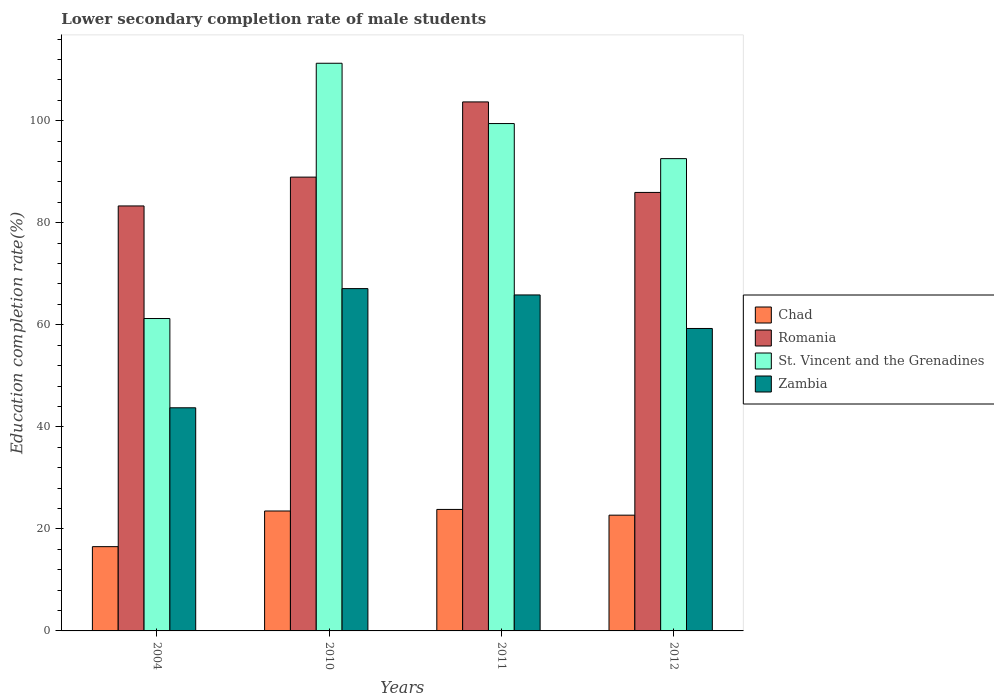How many different coloured bars are there?
Ensure brevity in your answer.  4. Are the number of bars per tick equal to the number of legend labels?
Your response must be concise. Yes. What is the label of the 2nd group of bars from the left?
Your answer should be compact. 2010. What is the lower secondary completion rate of male students in St. Vincent and the Grenadines in 2004?
Ensure brevity in your answer.  61.23. Across all years, what is the maximum lower secondary completion rate of male students in Chad?
Provide a short and direct response. 23.81. Across all years, what is the minimum lower secondary completion rate of male students in St. Vincent and the Grenadines?
Offer a terse response. 61.23. What is the total lower secondary completion rate of male students in Chad in the graph?
Your answer should be compact. 86.52. What is the difference between the lower secondary completion rate of male students in St. Vincent and the Grenadines in 2010 and that in 2012?
Your response must be concise. 18.69. What is the difference between the lower secondary completion rate of male students in Chad in 2010 and the lower secondary completion rate of male students in Zambia in 2004?
Offer a very short reply. -20.23. What is the average lower secondary completion rate of male students in Chad per year?
Provide a short and direct response. 21.63. In the year 2010, what is the difference between the lower secondary completion rate of male students in Romania and lower secondary completion rate of male students in St. Vincent and the Grenadines?
Offer a terse response. -22.31. In how many years, is the lower secondary completion rate of male students in Romania greater than 44 %?
Offer a terse response. 4. What is the ratio of the lower secondary completion rate of male students in Zambia in 2004 to that in 2012?
Your answer should be very brief. 0.74. Is the difference between the lower secondary completion rate of male students in Romania in 2004 and 2010 greater than the difference between the lower secondary completion rate of male students in St. Vincent and the Grenadines in 2004 and 2010?
Your answer should be very brief. Yes. What is the difference between the highest and the second highest lower secondary completion rate of male students in Romania?
Provide a short and direct response. 14.74. What is the difference between the highest and the lowest lower secondary completion rate of male students in Chad?
Provide a succinct answer. 7.3. Is the sum of the lower secondary completion rate of male students in St. Vincent and the Grenadines in 2011 and 2012 greater than the maximum lower secondary completion rate of male students in Chad across all years?
Your answer should be very brief. Yes. What does the 4th bar from the left in 2012 represents?
Keep it short and to the point. Zambia. What does the 1st bar from the right in 2011 represents?
Your response must be concise. Zambia. How many bars are there?
Provide a short and direct response. 16. What is the difference between two consecutive major ticks on the Y-axis?
Your response must be concise. 20. Are the values on the major ticks of Y-axis written in scientific E-notation?
Your response must be concise. No. Does the graph contain grids?
Make the answer very short. No. Where does the legend appear in the graph?
Your response must be concise. Center right. How many legend labels are there?
Ensure brevity in your answer.  4. What is the title of the graph?
Your response must be concise. Lower secondary completion rate of male students. What is the label or title of the Y-axis?
Your response must be concise. Education completion rate(%). What is the Education completion rate(%) in Chad in 2004?
Make the answer very short. 16.52. What is the Education completion rate(%) of Romania in 2004?
Offer a terse response. 83.29. What is the Education completion rate(%) in St. Vincent and the Grenadines in 2004?
Ensure brevity in your answer.  61.23. What is the Education completion rate(%) of Zambia in 2004?
Give a very brief answer. 43.73. What is the Education completion rate(%) of Chad in 2010?
Ensure brevity in your answer.  23.51. What is the Education completion rate(%) in Romania in 2010?
Provide a succinct answer. 88.94. What is the Education completion rate(%) of St. Vincent and the Grenadines in 2010?
Keep it short and to the point. 111.26. What is the Education completion rate(%) in Zambia in 2010?
Your answer should be very brief. 67.09. What is the Education completion rate(%) of Chad in 2011?
Your response must be concise. 23.81. What is the Education completion rate(%) in Romania in 2011?
Give a very brief answer. 103.68. What is the Education completion rate(%) of St. Vincent and the Grenadines in 2011?
Your response must be concise. 99.44. What is the Education completion rate(%) in Zambia in 2011?
Keep it short and to the point. 65.85. What is the Education completion rate(%) in Chad in 2012?
Provide a succinct answer. 22.69. What is the Education completion rate(%) in Romania in 2012?
Give a very brief answer. 85.94. What is the Education completion rate(%) in St. Vincent and the Grenadines in 2012?
Provide a short and direct response. 92.56. What is the Education completion rate(%) of Zambia in 2012?
Ensure brevity in your answer.  59.28. Across all years, what is the maximum Education completion rate(%) of Chad?
Your answer should be compact. 23.81. Across all years, what is the maximum Education completion rate(%) in Romania?
Offer a very short reply. 103.68. Across all years, what is the maximum Education completion rate(%) of St. Vincent and the Grenadines?
Provide a short and direct response. 111.26. Across all years, what is the maximum Education completion rate(%) of Zambia?
Your answer should be very brief. 67.09. Across all years, what is the minimum Education completion rate(%) in Chad?
Your response must be concise. 16.52. Across all years, what is the minimum Education completion rate(%) of Romania?
Ensure brevity in your answer.  83.29. Across all years, what is the minimum Education completion rate(%) in St. Vincent and the Grenadines?
Your answer should be compact. 61.23. Across all years, what is the minimum Education completion rate(%) in Zambia?
Offer a terse response. 43.73. What is the total Education completion rate(%) of Chad in the graph?
Offer a terse response. 86.52. What is the total Education completion rate(%) of Romania in the graph?
Your response must be concise. 361.85. What is the total Education completion rate(%) of St. Vincent and the Grenadines in the graph?
Keep it short and to the point. 364.48. What is the total Education completion rate(%) of Zambia in the graph?
Your answer should be compact. 235.95. What is the difference between the Education completion rate(%) in Chad in 2004 and that in 2010?
Offer a terse response. -6.99. What is the difference between the Education completion rate(%) of Romania in 2004 and that in 2010?
Ensure brevity in your answer.  -5.65. What is the difference between the Education completion rate(%) of St. Vincent and the Grenadines in 2004 and that in 2010?
Offer a very short reply. -50.03. What is the difference between the Education completion rate(%) in Zambia in 2004 and that in 2010?
Offer a very short reply. -23.36. What is the difference between the Education completion rate(%) in Chad in 2004 and that in 2011?
Keep it short and to the point. -7.3. What is the difference between the Education completion rate(%) in Romania in 2004 and that in 2011?
Your answer should be compact. -20.39. What is the difference between the Education completion rate(%) of St. Vincent and the Grenadines in 2004 and that in 2011?
Ensure brevity in your answer.  -38.21. What is the difference between the Education completion rate(%) of Zambia in 2004 and that in 2011?
Provide a succinct answer. -22.12. What is the difference between the Education completion rate(%) of Chad in 2004 and that in 2012?
Your response must be concise. -6.17. What is the difference between the Education completion rate(%) in Romania in 2004 and that in 2012?
Keep it short and to the point. -2.65. What is the difference between the Education completion rate(%) of St. Vincent and the Grenadines in 2004 and that in 2012?
Ensure brevity in your answer.  -31.34. What is the difference between the Education completion rate(%) of Zambia in 2004 and that in 2012?
Your answer should be very brief. -15.54. What is the difference between the Education completion rate(%) in Chad in 2010 and that in 2011?
Provide a short and direct response. -0.31. What is the difference between the Education completion rate(%) in Romania in 2010 and that in 2011?
Your answer should be very brief. -14.74. What is the difference between the Education completion rate(%) of St. Vincent and the Grenadines in 2010 and that in 2011?
Give a very brief answer. 11.82. What is the difference between the Education completion rate(%) in Zambia in 2010 and that in 2011?
Make the answer very short. 1.24. What is the difference between the Education completion rate(%) of Chad in 2010 and that in 2012?
Provide a succinct answer. 0.82. What is the difference between the Education completion rate(%) in Romania in 2010 and that in 2012?
Provide a succinct answer. 3. What is the difference between the Education completion rate(%) of St. Vincent and the Grenadines in 2010 and that in 2012?
Provide a short and direct response. 18.69. What is the difference between the Education completion rate(%) of Zambia in 2010 and that in 2012?
Offer a terse response. 7.82. What is the difference between the Education completion rate(%) of Chad in 2011 and that in 2012?
Your response must be concise. 1.12. What is the difference between the Education completion rate(%) of Romania in 2011 and that in 2012?
Your answer should be compact. 17.74. What is the difference between the Education completion rate(%) in St. Vincent and the Grenadines in 2011 and that in 2012?
Your response must be concise. 6.87. What is the difference between the Education completion rate(%) of Zambia in 2011 and that in 2012?
Offer a very short reply. 6.57. What is the difference between the Education completion rate(%) of Chad in 2004 and the Education completion rate(%) of Romania in 2010?
Offer a terse response. -72.42. What is the difference between the Education completion rate(%) of Chad in 2004 and the Education completion rate(%) of St. Vincent and the Grenadines in 2010?
Provide a short and direct response. -94.74. What is the difference between the Education completion rate(%) of Chad in 2004 and the Education completion rate(%) of Zambia in 2010?
Keep it short and to the point. -50.57. What is the difference between the Education completion rate(%) of Romania in 2004 and the Education completion rate(%) of St. Vincent and the Grenadines in 2010?
Provide a short and direct response. -27.96. What is the difference between the Education completion rate(%) of Romania in 2004 and the Education completion rate(%) of Zambia in 2010?
Your answer should be very brief. 16.2. What is the difference between the Education completion rate(%) of St. Vincent and the Grenadines in 2004 and the Education completion rate(%) of Zambia in 2010?
Provide a short and direct response. -5.87. What is the difference between the Education completion rate(%) of Chad in 2004 and the Education completion rate(%) of Romania in 2011?
Keep it short and to the point. -87.16. What is the difference between the Education completion rate(%) in Chad in 2004 and the Education completion rate(%) in St. Vincent and the Grenadines in 2011?
Provide a short and direct response. -82.92. What is the difference between the Education completion rate(%) in Chad in 2004 and the Education completion rate(%) in Zambia in 2011?
Provide a short and direct response. -49.33. What is the difference between the Education completion rate(%) of Romania in 2004 and the Education completion rate(%) of St. Vincent and the Grenadines in 2011?
Your answer should be very brief. -16.15. What is the difference between the Education completion rate(%) of Romania in 2004 and the Education completion rate(%) of Zambia in 2011?
Make the answer very short. 17.44. What is the difference between the Education completion rate(%) of St. Vincent and the Grenadines in 2004 and the Education completion rate(%) of Zambia in 2011?
Give a very brief answer. -4.62. What is the difference between the Education completion rate(%) of Chad in 2004 and the Education completion rate(%) of Romania in 2012?
Provide a succinct answer. -69.42. What is the difference between the Education completion rate(%) of Chad in 2004 and the Education completion rate(%) of St. Vincent and the Grenadines in 2012?
Ensure brevity in your answer.  -76.05. What is the difference between the Education completion rate(%) in Chad in 2004 and the Education completion rate(%) in Zambia in 2012?
Offer a very short reply. -42.76. What is the difference between the Education completion rate(%) in Romania in 2004 and the Education completion rate(%) in St. Vincent and the Grenadines in 2012?
Provide a succinct answer. -9.27. What is the difference between the Education completion rate(%) of Romania in 2004 and the Education completion rate(%) of Zambia in 2012?
Give a very brief answer. 24.02. What is the difference between the Education completion rate(%) of St. Vincent and the Grenadines in 2004 and the Education completion rate(%) of Zambia in 2012?
Keep it short and to the point. 1.95. What is the difference between the Education completion rate(%) of Chad in 2010 and the Education completion rate(%) of Romania in 2011?
Provide a succinct answer. -80.17. What is the difference between the Education completion rate(%) of Chad in 2010 and the Education completion rate(%) of St. Vincent and the Grenadines in 2011?
Give a very brief answer. -75.93. What is the difference between the Education completion rate(%) in Chad in 2010 and the Education completion rate(%) in Zambia in 2011?
Offer a terse response. -42.34. What is the difference between the Education completion rate(%) of Romania in 2010 and the Education completion rate(%) of St. Vincent and the Grenadines in 2011?
Offer a very short reply. -10.5. What is the difference between the Education completion rate(%) of Romania in 2010 and the Education completion rate(%) of Zambia in 2011?
Make the answer very short. 23.09. What is the difference between the Education completion rate(%) of St. Vincent and the Grenadines in 2010 and the Education completion rate(%) of Zambia in 2011?
Provide a short and direct response. 45.41. What is the difference between the Education completion rate(%) of Chad in 2010 and the Education completion rate(%) of Romania in 2012?
Make the answer very short. -62.43. What is the difference between the Education completion rate(%) in Chad in 2010 and the Education completion rate(%) in St. Vincent and the Grenadines in 2012?
Provide a succinct answer. -69.06. What is the difference between the Education completion rate(%) in Chad in 2010 and the Education completion rate(%) in Zambia in 2012?
Ensure brevity in your answer.  -35.77. What is the difference between the Education completion rate(%) in Romania in 2010 and the Education completion rate(%) in St. Vincent and the Grenadines in 2012?
Offer a terse response. -3.62. What is the difference between the Education completion rate(%) in Romania in 2010 and the Education completion rate(%) in Zambia in 2012?
Make the answer very short. 29.67. What is the difference between the Education completion rate(%) of St. Vincent and the Grenadines in 2010 and the Education completion rate(%) of Zambia in 2012?
Give a very brief answer. 51.98. What is the difference between the Education completion rate(%) of Chad in 2011 and the Education completion rate(%) of Romania in 2012?
Ensure brevity in your answer.  -62.13. What is the difference between the Education completion rate(%) of Chad in 2011 and the Education completion rate(%) of St. Vincent and the Grenadines in 2012?
Your response must be concise. -68.75. What is the difference between the Education completion rate(%) in Chad in 2011 and the Education completion rate(%) in Zambia in 2012?
Provide a succinct answer. -35.46. What is the difference between the Education completion rate(%) in Romania in 2011 and the Education completion rate(%) in St. Vincent and the Grenadines in 2012?
Keep it short and to the point. 11.12. What is the difference between the Education completion rate(%) of Romania in 2011 and the Education completion rate(%) of Zambia in 2012?
Give a very brief answer. 44.4. What is the difference between the Education completion rate(%) in St. Vincent and the Grenadines in 2011 and the Education completion rate(%) in Zambia in 2012?
Provide a short and direct response. 40.16. What is the average Education completion rate(%) in Chad per year?
Your answer should be very brief. 21.63. What is the average Education completion rate(%) in Romania per year?
Your response must be concise. 90.46. What is the average Education completion rate(%) of St. Vincent and the Grenadines per year?
Keep it short and to the point. 91.12. What is the average Education completion rate(%) of Zambia per year?
Provide a succinct answer. 58.99. In the year 2004, what is the difference between the Education completion rate(%) in Chad and Education completion rate(%) in Romania?
Ensure brevity in your answer.  -66.77. In the year 2004, what is the difference between the Education completion rate(%) in Chad and Education completion rate(%) in St. Vincent and the Grenadines?
Give a very brief answer. -44.71. In the year 2004, what is the difference between the Education completion rate(%) of Chad and Education completion rate(%) of Zambia?
Offer a very short reply. -27.21. In the year 2004, what is the difference between the Education completion rate(%) in Romania and Education completion rate(%) in St. Vincent and the Grenadines?
Provide a short and direct response. 22.07. In the year 2004, what is the difference between the Education completion rate(%) in Romania and Education completion rate(%) in Zambia?
Keep it short and to the point. 39.56. In the year 2004, what is the difference between the Education completion rate(%) in St. Vincent and the Grenadines and Education completion rate(%) in Zambia?
Your answer should be compact. 17.5. In the year 2010, what is the difference between the Education completion rate(%) of Chad and Education completion rate(%) of Romania?
Make the answer very short. -65.44. In the year 2010, what is the difference between the Education completion rate(%) of Chad and Education completion rate(%) of St. Vincent and the Grenadines?
Offer a terse response. -87.75. In the year 2010, what is the difference between the Education completion rate(%) in Chad and Education completion rate(%) in Zambia?
Your answer should be very brief. -43.59. In the year 2010, what is the difference between the Education completion rate(%) in Romania and Education completion rate(%) in St. Vincent and the Grenadines?
Your answer should be compact. -22.31. In the year 2010, what is the difference between the Education completion rate(%) of Romania and Education completion rate(%) of Zambia?
Ensure brevity in your answer.  21.85. In the year 2010, what is the difference between the Education completion rate(%) of St. Vincent and the Grenadines and Education completion rate(%) of Zambia?
Your response must be concise. 44.16. In the year 2011, what is the difference between the Education completion rate(%) of Chad and Education completion rate(%) of Romania?
Your answer should be very brief. -79.87. In the year 2011, what is the difference between the Education completion rate(%) in Chad and Education completion rate(%) in St. Vincent and the Grenadines?
Offer a terse response. -75.63. In the year 2011, what is the difference between the Education completion rate(%) in Chad and Education completion rate(%) in Zambia?
Your response must be concise. -42.04. In the year 2011, what is the difference between the Education completion rate(%) in Romania and Education completion rate(%) in St. Vincent and the Grenadines?
Offer a very short reply. 4.24. In the year 2011, what is the difference between the Education completion rate(%) in Romania and Education completion rate(%) in Zambia?
Provide a short and direct response. 37.83. In the year 2011, what is the difference between the Education completion rate(%) in St. Vincent and the Grenadines and Education completion rate(%) in Zambia?
Make the answer very short. 33.59. In the year 2012, what is the difference between the Education completion rate(%) in Chad and Education completion rate(%) in Romania?
Provide a short and direct response. -63.25. In the year 2012, what is the difference between the Education completion rate(%) in Chad and Education completion rate(%) in St. Vincent and the Grenadines?
Keep it short and to the point. -69.88. In the year 2012, what is the difference between the Education completion rate(%) in Chad and Education completion rate(%) in Zambia?
Offer a very short reply. -36.59. In the year 2012, what is the difference between the Education completion rate(%) of Romania and Education completion rate(%) of St. Vincent and the Grenadines?
Ensure brevity in your answer.  -6.62. In the year 2012, what is the difference between the Education completion rate(%) in Romania and Education completion rate(%) in Zambia?
Ensure brevity in your answer.  26.66. In the year 2012, what is the difference between the Education completion rate(%) in St. Vincent and the Grenadines and Education completion rate(%) in Zambia?
Give a very brief answer. 33.29. What is the ratio of the Education completion rate(%) in Chad in 2004 to that in 2010?
Ensure brevity in your answer.  0.7. What is the ratio of the Education completion rate(%) of Romania in 2004 to that in 2010?
Your answer should be very brief. 0.94. What is the ratio of the Education completion rate(%) of St. Vincent and the Grenadines in 2004 to that in 2010?
Keep it short and to the point. 0.55. What is the ratio of the Education completion rate(%) of Zambia in 2004 to that in 2010?
Provide a short and direct response. 0.65. What is the ratio of the Education completion rate(%) of Chad in 2004 to that in 2011?
Offer a terse response. 0.69. What is the ratio of the Education completion rate(%) in Romania in 2004 to that in 2011?
Provide a short and direct response. 0.8. What is the ratio of the Education completion rate(%) of St. Vincent and the Grenadines in 2004 to that in 2011?
Keep it short and to the point. 0.62. What is the ratio of the Education completion rate(%) in Zambia in 2004 to that in 2011?
Give a very brief answer. 0.66. What is the ratio of the Education completion rate(%) in Chad in 2004 to that in 2012?
Your response must be concise. 0.73. What is the ratio of the Education completion rate(%) in Romania in 2004 to that in 2012?
Offer a terse response. 0.97. What is the ratio of the Education completion rate(%) of St. Vincent and the Grenadines in 2004 to that in 2012?
Ensure brevity in your answer.  0.66. What is the ratio of the Education completion rate(%) in Zambia in 2004 to that in 2012?
Your answer should be very brief. 0.74. What is the ratio of the Education completion rate(%) of Chad in 2010 to that in 2011?
Your response must be concise. 0.99. What is the ratio of the Education completion rate(%) of Romania in 2010 to that in 2011?
Provide a succinct answer. 0.86. What is the ratio of the Education completion rate(%) in St. Vincent and the Grenadines in 2010 to that in 2011?
Ensure brevity in your answer.  1.12. What is the ratio of the Education completion rate(%) of Zambia in 2010 to that in 2011?
Offer a very short reply. 1.02. What is the ratio of the Education completion rate(%) of Chad in 2010 to that in 2012?
Make the answer very short. 1.04. What is the ratio of the Education completion rate(%) of Romania in 2010 to that in 2012?
Give a very brief answer. 1.03. What is the ratio of the Education completion rate(%) of St. Vincent and the Grenadines in 2010 to that in 2012?
Make the answer very short. 1.2. What is the ratio of the Education completion rate(%) in Zambia in 2010 to that in 2012?
Provide a succinct answer. 1.13. What is the ratio of the Education completion rate(%) in Chad in 2011 to that in 2012?
Ensure brevity in your answer.  1.05. What is the ratio of the Education completion rate(%) in Romania in 2011 to that in 2012?
Keep it short and to the point. 1.21. What is the ratio of the Education completion rate(%) of St. Vincent and the Grenadines in 2011 to that in 2012?
Give a very brief answer. 1.07. What is the ratio of the Education completion rate(%) in Zambia in 2011 to that in 2012?
Your answer should be very brief. 1.11. What is the difference between the highest and the second highest Education completion rate(%) in Chad?
Keep it short and to the point. 0.31. What is the difference between the highest and the second highest Education completion rate(%) of Romania?
Your answer should be compact. 14.74. What is the difference between the highest and the second highest Education completion rate(%) of St. Vincent and the Grenadines?
Your answer should be very brief. 11.82. What is the difference between the highest and the second highest Education completion rate(%) in Zambia?
Provide a short and direct response. 1.24. What is the difference between the highest and the lowest Education completion rate(%) of Chad?
Provide a short and direct response. 7.3. What is the difference between the highest and the lowest Education completion rate(%) of Romania?
Make the answer very short. 20.39. What is the difference between the highest and the lowest Education completion rate(%) of St. Vincent and the Grenadines?
Provide a short and direct response. 50.03. What is the difference between the highest and the lowest Education completion rate(%) of Zambia?
Offer a terse response. 23.36. 